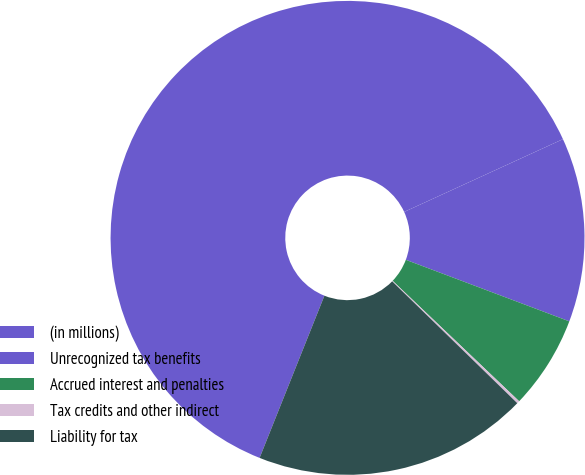Convert chart to OTSL. <chart><loc_0><loc_0><loc_500><loc_500><pie_chart><fcel>(in millions)<fcel>Unrecognized tax benefits<fcel>Accrued interest and penalties<fcel>Tax credits and other indirect<fcel>Liability for tax<nl><fcel>62.11%<fcel>12.57%<fcel>6.38%<fcel>0.18%<fcel>18.76%<nl></chart> 